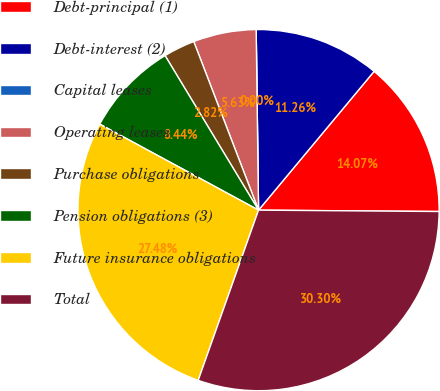Convert chart to OTSL. <chart><loc_0><loc_0><loc_500><loc_500><pie_chart><fcel>Debt-principal (1)<fcel>Debt-interest (2)<fcel>Capital leases<fcel>Operating leases<fcel>Purchase obligations<fcel>Pension obligations (3)<fcel>Future insurance obligations<fcel>Total<nl><fcel>14.07%<fcel>11.26%<fcel>0.0%<fcel>5.63%<fcel>2.82%<fcel>8.44%<fcel>27.48%<fcel>30.3%<nl></chart> 